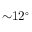Convert formula to latex. <formula><loc_0><loc_0><loc_500><loc_500>{ \sim } 1 2 ^ { \circ }</formula> 